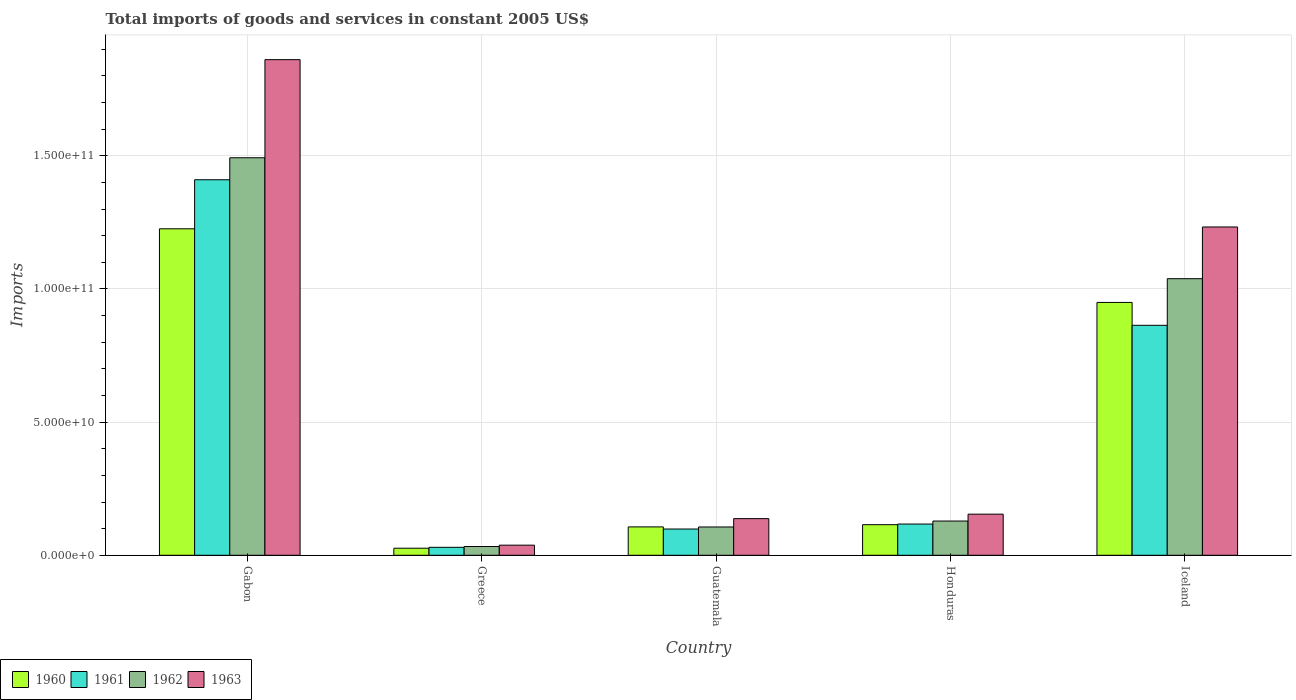How many different coloured bars are there?
Make the answer very short. 4. Are the number of bars per tick equal to the number of legend labels?
Your answer should be very brief. Yes. Are the number of bars on each tick of the X-axis equal?
Ensure brevity in your answer.  Yes. What is the label of the 4th group of bars from the left?
Provide a succinct answer. Honduras. What is the total imports of goods and services in 1960 in Guatemala?
Provide a short and direct response. 1.07e+1. Across all countries, what is the maximum total imports of goods and services in 1963?
Offer a very short reply. 1.86e+11. Across all countries, what is the minimum total imports of goods and services in 1962?
Make the answer very short. 3.29e+09. In which country was the total imports of goods and services in 1961 maximum?
Your response must be concise. Gabon. What is the total total imports of goods and services in 1960 in the graph?
Your answer should be very brief. 2.42e+11. What is the difference between the total imports of goods and services in 1960 in Gabon and that in Honduras?
Your response must be concise. 1.11e+11. What is the difference between the total imports of goods and services in 1961 in Iceland and the total imports of goods and services in 1962 in Gabon?
Your answer should be very brief. -6.29e+1. What is the average total imports of goods and services in 1961 per country?
Your response must be concise. 5.04e+1. What is the difference between the total imports of goods and services of/in 1960 and total imports of goods and services of/in 1961 in Gabon?
Give a very brief answer. -1.84e+1. What is the ratio of the total imports of goods and services in 1961 in Guatemala to that in Honduras?
Provide a succinct answer. 0.84. Is the total imports of goods and services in 1962 in Gabon less than that in Iceland?
Make the answer very short. No. What is the difference between the highest and the second highest total imports of goods and services in 1960?
Make the answer very short. -1.11e+11. What is the difference between the highest and the lowest total imports of goods and services in 1960?
Your response must be concise. 1.20e+11. In how many countries, is the total imports of goods and services in 1962 greater than the average total imports of goods and services in 1962 taken over all countries?
Ensure brevity in your answer.  2. Is the sum of the total imports of goods and services in 1961 in Guatemala and Iceland greater than the maximum total imports of goods and services in 1962 across all countries?
Your answer should be compact. No. Is it the case that in every country, the sum of the total imports of goods and services in 1962 and total imports of goods and services in 1961 is greater than the sum of total imports of goods and services in 1963 and total imports of goods and services in 1960?
Your response must be concise. No. What does the 4th bar from the left in Greece represents?
Provide a succinct answer. 1963. Is it the case that in every country, the sum of the total imports of goods and services in 1961 and total imports of goods and services in 1962 is greater than the total imports of goods and services in 1963?
Give a very brief answer. Yes. Are all the bars in the graph horizontal?
Keep it short and to the point. No. How many countries are there in the graph?
Give a very brief answer. 5. What is the difference between two consecutive major ticks on the Y-axis?
Make the answer very short. 5.00e+1. Are the values on the major ticks of Y-axis written in scientific E-notation?
Provide a succinct answer. Yes. How many legend labels are there?
Provide a succinct answer. 4. What is the title of the graph?
Your answer should be compact. Total imports of goods and services in constant 2005 US$. Does "1994" appear as one of the legend labels in the graph?
Your response must be concise. No. What is the label or title of the Y-axis?
Give a very brief answer. Imports. What is the Imports in 1960 in Gabon?
Your answer should be compact. 1.23e+11. What is the Imports of 1961 in Gabon?
Offer a very short reply. 1.41e+11. What is the Imports of 1962 in Gabon?
Provide a short and direct response. 1.49e+11. What is the Imports of 1963 in Gabon?
Make the answer very short. 1.86e+11. What is the Imports of 1960 in Greece?
Keep it short and to the point. 2.65e+09. What is the Imports of 1961 in Greece?
Ensure brevity in your answer.  2.99e+09. What is the Imports in 1962 in Greece?
Give a very brief answer. 3.29e+09. What is the Imports in 1963 in Greece?
Keep it short and to the point. 3.80e+09. What is the Imports in 1960 in Guatemala?
Keep it short and to the point. 1.07e+1. What is the Imports of 1961 in Guatemala?
Keep it short and to the point. 9.86e+09. What is the Imports of 1962 in Guatemala?
Your answer should be compact. 1.06e+1. What is the Imports of 1963 in Guatemala?
Your answer should be compact. 1.38e+1. What is the Imports of 1960 in Honduras?
Your response must be concise. 1.15e+1. What is the Imports of 1961 in Honduras?
Keep it short and to the point. 1.17e+1. What is the Imports of 1962 in Honduras?
Offer a terse response. 1.29e+1. What is the Imports of 1963 in Honduras?
Keep it short and to the point. 1.54e+1. What is the Imports in 1960 in Iceland?
Keep it short and to the point. 9.49e+1. What is the Imports of 1961 in Iceland?
Provide a short and direct response. 8.63e+1. What is the Imports in 1962 in Iceland?
Give a very brief answer. 1.04e+11. What is the Imports of 1963 in Iceland?
Provide a short and direct response. 1.23e+11. Across all countries, what is the maximum Imports in 1960?
Offer a very short reply. 1.23e+11. Across all countries, what is the maximum Imports of 1961?
Offer a very short reply. 1.41e+11. Across all countries, what is the maximum Imports of 1962?
Offer a terse response. 1.49e+11. Across all countries, what is the maximum Imports in 1963?
Provide a succinct answer. 1.86e+11. Across all countries, what is the minimum Imports of 1960?
Make the answer very short. 2.65e+09. Across all countries, what is the minimum Imports of 1961?
Keep it short and to the point. 2.99e+09. Across all countries, what is the minimum Imports in 1962?
Your answer should be compact. 3.29e+09. Across all countries, what is the minimum Imports in 1963?
Your response must be concise. 3.80e+09. What is the total Imports in 1960 in the graph?
Your answer should be very brief. 2.42e+11. What is the total Imports of 1961 in the graph?
Keep it short and to the point. 2.52e+11. What is the total Imports in 1962 in the graph?
Offer a terse response. 2.80e+11. What is the total Imports in 1963 in the graph?
Provide a succinct answer. 3.42e+11. What is the difference between the Imports of 1960 in Gabon and that in Greece?
Keep it short and to the point. 1.20e+11. What is the difference between the Imports in 1961 in Gabon and that in Greece?
Your response must be concise. 1.38e+11. What is the difference between the Imports in 1962 in Gabon and that in Greece?
Provide a succinct answer. 1.46e+11. What is the difference between the Imports in 1963 in Gabon and that in Greece?
Keep it short and to the point. 1.82e+11. What is the difference between the Imports of 1960 in Gabon and that in Guatemala?
Give a very brief answer. 1.12e+11. What is the difference between the Imports in 1961 in Gabon and that in Guatemala?
Keep it short and to the point. 1.31e+11. What is the difference between the Imports of 1962 in Gabon and that in Guatemala?
Provide a short and direct response. 1.39e+11. What is the difference between the Imports in 1963 in Gabon and that in Guatemala?
Your answer should be compact. 1.72e+11. What is the difference between the Imports of 1960 in Gabon and that in Honduras?
Ensure brevity in your answer.  1.11e+11. What is the difference between the Imports of 1961 in Gabon and that in Honduras?
Offer a terse response. 1.29e+11. What is the difference between the Imports in 1962 in Gabon and that in Honduras?
Your answer should be very brief. 1.36e+11. What is the difference between the Imports in 1963 in Gabon and that in Honduras?
Offer a terse response. 1.71e+11. What is the difference between the Imports of 1960 in Gabon and that in Iceland?
Make the answer very short. 2.76e+1. What is the difference between the Imports in 1961 in Gabon and that in Iceland?
Ensure brevity in your answer.  5.47e+1. What is the difference between the Imports in 1962 in Gabon and that in Iceland?
Offer a terse response. 4.54e+1. What is the difference between the Imports in 1963 in Gabon and that in Iceland?
Provide a short and direct response. 6.28e+1. What is the difference between the Imports of 1960 in Greece and that in Guatemala?
Ensure brevity in your answer.  -8.00e+09. What is the difference between the Imports of 1961 in Greece and that in Guatemala?
Your response must be concise. -6.87e+09. What is the difference between the Imports in 1962 in Greece and that in Guatemala?
Make the answer very short. -7.34e+09. What is the difference between the Imports in 1963 in Greece and that in Guatemala?
Your answer should be very brief. -9.96e+09. What is the difference between the Imports in 1960 in Greece and that in Honduras?
Provide a succinct answer. -8.83e+09. What is the difference between the Imports of 1961 in Greece and that in Honduras?
Provide a short and direct response. -8.74e+09. What is the difference between the Imports of 1962 in Greece and that in Honduras?
Keep it short and to the point. -9.56e+09. What is the difference between the Imports in 1963 in Greece and that in Honduras?
Your answer should be compact. -1.16e+1. What is the difference between the Imports of 1960 in Greece and that in Iceland?
Provide a short and direct response. -9.23e+1. What is the difference between the Imports in 1961 in Greece and that in Iceland?
Your response must be concise. -8.34e+1. What is the difference between the Imports of 1962 in Greece and that in Iceland?
Provide a succinct answer. -1.01e+11. What is the difference between the Imports of 1963 in Greece and that in Iceland?
Give a very brief answer. -1.19e+11. What is the difference between the Imports of 1960 in Guatemala and that in Honduras?
Provide a short and direct response. -8.33e+08. What is the difference between the Imports in 1961 in Guatemala and that in Honduras?
Keep it short and to the point. -1.87e+09. What is the difference between the Imports of 1962 in Guatemala and that in Honduras?
Provide a succinct answer. -2.23e+09. What is the difference between the Imports in 1963 in Guatemala and that in Honduras?
Provide a succinct answer. -1.68e+09. What is the difference between the Imports in 1960 in Guatemala and that in Iceland?
Your response must be concise. -8.43e+1. What is the difference between the Imports in 1961 in Guatemala and that in Iceland?
Offer a very short reply. -7.65e+1. What is the difference between the Imports in 1962 in Guatemala and that in Iceland?
Make the answer very short. -9.32e+1. What is the difference between the Imports in 1963 in Guatemala and that in Iceland?
Offer a very short reply. -1.10e+11. What is the difference between the Imports in 1960 in Honduras and that in Iceland?
Provide a short and direct response. -8.34e+1. What is the difference between the Imports of 1961 in Honduras and that in Iceland?
Give a very brief answer. -7.46e+1. What is the difference between the Imports of 1962 in Honduras and that in Iceland?
Make the answer very short. -9.10e+1. What is the difference between the Imports of 1963 in Honduras and that in Iceland?
Provide a succinct answer. -1.08e+11. What is the difference between the Imports in 1960 in Gabon and the Imports in 1961 in Greece?
Your response must be concise. 1.20e+11. What is the difference between the Imports in 1960 in Gabon and the Imports in 1962 in Greece?
Your answer should be very brief. 1.19e+11. What is the difference between the Imports of 1960 in Gabon and the Imports of 1963 in Greece?
Provide a succinct answer. 1.19e+11. What is the difference between the Imports of 1961 in Gabon and the Imports of 1962 in Greece?
Provide a succinct answer. 1.38e+11. What is the difference between the Imports of 1961 in Gabon and the Imports of 1963 in Greece?
Keep it short and to the point. 1.37e+11. What is the difference between the Imports in 1962 in Gabon and the Imports in 1963 in Greece?
Your response must be concise. 1.45e+11. What is the difference between the Imports in 1960 in Gabon and the Imports in 1961 in Guatemala?
Your answer should be very brief. 1.13e+11. What is the difference between the Imports in 1960 in Gabon and the Imports in 1962 in Guatemala?
Give a very brief answer. 1.12e+11. What is the difference between the Imports of 1960 in Gabon and the Imports of 1963 in Guatemala?
Your answer should be compact. 1.09e+11. What is the difference between the Imports in 1961 in Gabon and the Imports in 1962 in Guatemala?
Provide a succinct answer. 1.30e+11. What is the difference between the Imports of 1961 in Gabon and the Imports of 1963 in Guatemala?
Make the answer very short. 1.27e+11. What is the difference between the Imports in 1962 in Gabon and the Imports in 1963 in Guatemala?
Give a very brief answer. 1.35e+11. What is the difference between the Imports of 1960 in Gabon and the Imports of 1961 in Honduras?
Give a very brief answer. 1.11e+11. What is the difference between the Imports of 1960 in Gabon and the Imports of 1962 in Honduras?
Provide a short and direct response. 1.10e+11. What is the difference between the Imports in 1960 in Gabon and the Imports in 1963 in Honduras?
Give a very brief answer. 1.07e+11. What is the difference between the Imports in 1961 in Gabon and the Imports in 1962 in Honduras?
Make the answer very short. 1.28e+11. What is the difference between the Imports in 1961 in Gabon and the Imports in 1963 in Honduras?
Give a very brief answer. 1.26e+11. What is the difference between the Imports of 1962 in Gabon and the Imports of 1963 in Honduras?
Offer a terse response. 1.34e+11. What is the difference between the Imports of 1960 in Gabon and the Imports of 1961 in Iceland?
Your answer should be very brief. 3.62e+1. What is the difference between the Imports in 1960 in Gabon and the Imports in 1962 in Iceland?
Your answer should be compact. 1.87e+1. What is the difference between the Imports of 1960 in Gabon and the Imports of 1963 in Iceland?
Keep it short and to the point. -6.90e+08. What is the difference between the Imports of 1961 in Gabon and the Imports of 1962 in Iceland?
Make the answer very short. 3.71e+1. What is the difference between the Imports of 1961 in Gabon and the Imports of 1963 in Iceland?
Ensure brevity in your answer.  1.77e+1. What is the difference between the Imports in 1962 in Gabon and the Imports in 1963 in Iceland?
Provide a short and direct response. 2.60e+1. What is the difference between the Imports of 1960 in Greece and the Imports of 1961 in Guatemala?
Your response must be concise. -7.21e+09. What is the difference between the Imports in 1960 in Greece and the Imports in 1962 in Guatemala?
Ensure brevity in your answer.  -7.97e+09. What is the difference between the Imports of 1960 in Greece and the Imports of 1963 in Guatemala?
Your answer should be very brief. -1.11e+1. What is the difference between the Imports of 1961 in Greece and the Imports of 1962 in Guatemala?
Your response must be concise. -7.64e+09. What is the difference between the Imports in 1961 in Greece and the Imports in 1963 in Guatemala?
Your response must be concise. -1.08e+1. What is the difference between the Imports of 1962 in Greece and the Imports of 1963 in Guatemala?
Provide a succinct answer. -1.05e+1. What is the difference between the Imports of 1960 in Greece and the Imports of 1961 in Honduras?
Provide a succinct answer. -9.08e+09. What is the difference between the Imports of 1960 in Greece and the Imports of 1962 in Honduras?
Make the answer very short. -1.02e+1. What is the difference between the Imports of 1960 in Greece and the Imports of 1963 in Honduras?
Your answer should be compact. -1.28e+1. What is the difference between the Imports of 1961 in Greece and the Imports of 1962 in Honduras?
Your answer should be very brief. -9.86e+09. What is the difference between the Imports in 1961 in Greece and the Imports in 1963 in Honduras?
Your answer should be compact. -1.24e+1. What is the difference between the Imports in 1962 in Greece and the Imports in 1963 in Honduras?
Provide a succinct answer. -1.21e+1. What is the difference between the Imports in 1960 in Greece and the Imports in 1961 in Iceland?
Provide a succinct answer. -8.37e+1. What is the difference between the Imports of 1960 in Greece and the Imports of 1962 in Iceland?
Your answer should be very brief. -1.01e+11. What is the difference between the Imports of 1960 in Greece and the Imports of 1963 in Iceland?
Your answer should be compact. -1.21e+11. What is the difference between the Imports of 1961 in Greece and the Imports of 1962 in Iceland?
Ensure brevity in your answer.  -1.01e+11. What is the difference between the Imports in 1961 in Greece and the Imports in 1963 in Iceland?
Provide a succinct answer. -1.20e+11. What is the difference between the Imports of 1962 in Greece and the Imports of 1963 in Iceland?
Give a very brief answer. -1.20e+11. What is the difference between the Imports of 1960 in Guatemala and the Imports of 1961 in Honduras?
Keep it short and to the point. -1.08e+09. What is the difference between the Imports of 1960 in Guatemala and the Imports of 1962 in Honduras?
Ensure brevity in your answer.  -2.20e+09. What is the difference between the Imports in 1960 in Guatemala and the Imports in 1963 in Honduras?
Your answer should be compact. -4.78e+09. What is the difference between the Imports of 1961 in Guatemala and the Imports of 1962 in Honduras?
Your answer should be compact. -2.99e+09. What is the difference between the Imports in 1961 in Guatemala and the Imports in 1963 in Honduras?
Your answer should be very brief. -5.58e+09. What is the difference between the Imports of 1962 in Guatemala and the Imports of 1963 in Honduras?
Provide a succinct answer. -4.81e+09. What is the difference between the Imports of 1960 in Guatemala and the Imports of 1961 in Iceland?
Ensure brevity in your answer.  -7.57e+1. What is the difference between the Imports of 1960 in Guatemala and the Imports of 1962 in Iceland?
Your answer should be compact. -9.32e+1. What is the difference between the Imports in 1960 in Guatemala and the Imports in 1963 in Iceland?
Your answer should be very brief. -1.13e+11. What is the difference between the Imports of 1961 in Guatemala and the Imports of 1962 in Iceland?
Your answer should be very brief. -9.40e+1. What is the difference between the Imports in 1961 in Guatemala and the Imports in 1963 in Iceland?
Ensure brevity in your answer.  -1.13e+11. What is the difference between the Imports in 1962 in Guatemala and the Imports in 1963 in Iceland?
Offer a very short reply. -1.13e+11. What is the difference between the Imports of 1960 in Honduras and the Imports of 1961 in Iceland?
Offer a terse response. -7.49e+1. What is the difference between the Imports of 1960 in Honduras and the Imports of 1962 in Iceland?
Your answer should be compact. -9.24e+1. What is the difference between the Imports of 1960 in Honduras and the Imports of 1963 in Iceland?
Your response must be concise. -1.12e+11. What is the difference between the Imports of 1961 in Honduras and the Imports of 1962 in Iceland?
Your response must be concise. -9.21e+1. What is the difference between the Imports of 1961 in Honduras and the Imports of 1963 in Iceland?
Provide a succinct answer. -1.12e+11. What is the difference between the Imports in 1962 in Honduras and the Imports in 1963 in Iceland?
Offer a terse response. -1.10e+11. What is the average Imports of 1960 per country?
Offer a terse response. 4.85e+1. What is the average Imports of 1961 per country?
Provide a short and direct response. 5.04e+1. What is the average Imports in 1962 per country?
Offer a terse response. 5.60e+1. What is the average Imports of 1963 per country?
Keep it short and to the point. 6.85e+1. What is the difference between the Imports of 1960 and Imports of 1961 in Gabon?
Provide a short and direct response. -1.84e+1. What is the difference between the Imports of 1960 and Imports of 1962 in Gabon?
Provide a short and direct response. -2.67e+1. What is the difference between the Imports in 1960 and Imports in 1963 in Gabon?
Keep it short and to the point. -6.35e+1. What is the difference between the Imports in 1961 and Imports in 1962 in Gabon?
Your response must be concise. -8.26e+09. What is the difference between the Imports in 1961 and Imports in 1963 in Gabon?
Give a very brief answer. -4.51e+1. What is the difference between the Imports in 1962 and Imports in 1963 in Gabon?
Give a very brief answer. -3.68e+1. What is the difference between the Imports of 1960 and Imports of 1961 in Greece?
Offer a terse response. -3.37e+08. What is the difference between the Imports in 1960 and Imports in 1962 in Greece?
Keep it short and to the point. -6.39e+08. What is the difference between the Imports of 1960 and Imports of 1963 in Greece?
Keep it short and to the point. -1.15e+09. What is the difference between the Imports of 1961 and Imports of 1962 in Greece?
Ensure brevity in your answer.  -3.02e+08. What is the difference between the Imports in 1961 and Imports in 1963 in Greece?
Your answer should be compact. -8.09e+08. What is the difference between the Imports in 1962 and Imports in 1963 in Greece?
Offer a terse response. -5.06e+08. What is the difference between the Imports of 1960 and Imports of 1961 in Guatemala?
Keep it short and to the point. 7.93e+08. What is the difference between the Imports in 1960 and Imports in 1962 in Guatemala?
Offer a terse response. 2.58e+07. What is the difference between the Imports in 1960 and Imports in 1963 in Guatemala?
Provide a succinct answer. -3.11e+09. What is the difference between the Imports of 1961 and Imports of 1962 in Guatemala?
Make the answer very short. -7.67e+08. What is the difference between the Imports of 1961 and Imports of 1963 in Guatemala?
Ensure brevity in your answer.  -3.90e+09. What is the difference between the Imports in 1962 and Imports in 1963 in Guatemala?
Offer a very short reply. -3.13e+09. What is the difference between the Imports of 1960 and Imports of 1961 in Honduras?
Your answer should be compact. -2.44e+08. What is the difference between the Imports of 1960 and Imports of 1962 in Honduras?
Offer a terse response. -1.37e+09. What is the difference between the Imports of 1960 and Imports of 1963 in Honduras?
Keep it short and to the point. -3.95e+09. What is the difference between the Imports in 1961 and Imports in 1962 in Honduras?
Keep it short and to the point. -1.12e+09. What is the difference between the Imports in 1961 and Imports in 1963 in Honduras?
Give a very brief answer. -3.71e+09. What is the difference between the Imports in 1962 and Imports in 1963 in Honduras?
Keep it short and to the point. -2.58e+09. What is the difference between the Imports of 1960 and Imports of 1961 in Iceland?
Make the answer very short. 8.59e+09. What is the difference between the Imports of 1960 and Imports of 1962 in Iceland?
Your response must be concise. -8.91e+09. What is the difference between the Imports in 1960 and Imports in 1963 in Iceland?
Your response must be concise. -2.83e+1. What is the difference between the Imports of 1961 and Imports of 1962 in Iceland?
Give a very brief answer. -1.75e+1. What is the difference between the Imports in 1961 and Imports in 1963 in Iceland?
Make the answer very short. -3.69e+1. What is the difference between the Imports in 1962 and Imports in 1963 in Iceland?
Offer a terse response. -1.94e+1. What is the ratio of the Imports of 1960 in Gabon to that in Greece?
Ensure brevity in your answer.  46.22. What is the ratio of the Imports of 1961 in Gabon to that in Greece?
Offer a terse response. 47.18. What is the ratio of the Imports in 1962 in Gabon to that in Greece?
Make the answer very short. 45.35. What is the ratio of the Imports in 1963 in Gabon to that in Greece?
Offer a very short reply. 49. What is the ratio of the Imports in 1960 in Gabon to that in Guatemala?
Give a very brief answer. 11.51. What is the ratio of the Imports in 1961 in Gabon to that in Guatemala?
Give a very brief answer. 14.3. What is the ratio of the Imports of 1962 in Gabon to that in Guatemala?
Give a very brief answer. 14.05. What is the ratio of the Imports in 1963 in Gabon to that in Guatemala?
Offer a terse response. 13.52. What is the ratio of the Imports of 1960 in Gabon to that in Honduras?
Offer a very short reply. 10.67. What is the ratio of the Imports of 1961 in Gabon to that in Honduras?
Ensure brevity in your answer.  12.02. What is the ratio of the Imports in 1962 in Gabon to that in Honduras?
Offer a very short reply. 11.61. What is the ratio of the Imports in 1963 in Gabon to that in Honduras?
Make the answer very short. 12.06. What is the ratio of the Imports of 1960 in Gabon to that in Iceland?
Your answer should be very brief. 1.29. What is the ratio of the Imports in 1961 in Gabon to that in Iceland?
Make the answer very short. 1.63. What is the ratio of the Imports in 1962 in Gabon to that in Iceland?
Ensure brevity in your answer.  1.44. What is the ratio of the Imports in 1963 in Gabon to that in Iceland?
Give a very brief answer. 1.51. What is the ratio of the Imports of 1960 in Greece to that in Guatemala?
Your answer should be very brief. 0.25. What is the ratio of the Imports in 1961 in Greece to that in Guatemala?
Keep it short and to the point. 0.3. What is the ratio of the Imports of 1962 in Greece to that in Guatemala?
Ensure brevity in your answer.  0.31. What is the ratio of the Imports in 1963 in Greece to that in Guatemala?
Provide a short and direct response. 0.28. What is the ratio of the Imports in 1960 in Greece to that in Honduras?
Provide a short and direct response. 0.23. What is the ratio of the Imports of 1961 in Greece to that in Honduras?
Offer a very short reply. 0.25. What is the ratio of the Imports of 1962 in Greece to that in Honduras?
Keep it short and to the point. 0.26. What is the ratio of the Imports of 1963 in Greece to that in Honduras?
Offer a very short reply. 0.25. What is the ratio of the Imports of 1960 in Greece to that in Iceland?
Your answer should be very brief. 0.03. What is the ratio of the Imports in 1961 in Greece to that in Iceland?
Provide a succinct answer. 0.03. What is the ratio of the Imports in 1962 in Greece to that in Iceland?
Ensure brevity in your answer.  0.03. What is the ratio of the Imports of 1963 in Greece to that in Iceland?
Offer a terse response. 0.03. What is the ratio of the Imports of 1960 in Guatemala to that in Honduras?
Your response must be concise. 0.93. What is the ratio of the Imports of 1961 in Guatemala to that in Honduras?
Give a very brief answer. 0.84. What is the ratio of the Imports of 1962 in Guatemala to that in Honduras?
Provide a succinct answer. 0.83. What is the ratio of the Imports in 1963 in Guatemala to that in Honduras?
Your answer should be very brief. 0.89. What is the ratio of the Imports in 1960 in Guatemala to that in Iceland?
Offer a very short reply. 0.11. What is the ratio of the Imports in 1961 in Guatemala to that in Iceland?
Give a very brief answer. 0.11. What is the ratio of the Imports of 1962 in Guatemala to that in Iceland?
Give a very brief answer. 0.1. What is the ratio of the Imports of 1963 in Guatemala to that in Iceland?
Keep it short and to the point. 0.11. What is the ratio of the Imports of 1960 in Honduras to that in Iceland?
Your answer should be very brief. 0.12. What is the ratio of the Imports of 1961 in Honduras to that in Iceland?
Ensure brevity in your answer.  0.14. What is the ratio of the Imports in 1962 in Honduras to that in Iceland?
Provide a succinct answer. 0.12. What is the ratio of the Imports of 1963 in Honduras to that in Iceland?
Give a very brief answer. 0.13. What is the difference between the highest and the second highest Imports of 1960?
Offer a terse response. 2.76e+1. What is the difference between the highest and the second highest Imports in 1961?
Give a very brief answer. 5.47e+1. What is the difference between the highest and the second highest Imports of 1962?
Your answer should be very brief. 4.54e+1. What is the difference between the highest and the second highest Imports of 1963?
Provide a succinct answer. 6.28e+1. What is the difference between the highest and the lowest Imports of 1960?
Provide a short and direct response. 1.20e+11. What is the difference between the highest and the lowest Imports of 1961?
Offer a terse response. 1.38e+11. What is the difference between the highest and the lowest Imports in 1962?
Provide a short and direct response. 1.46e+11. What is the difference between the highest and the lowest Imports in 1963?
Provide a succinct answer. 1.82e+11. 